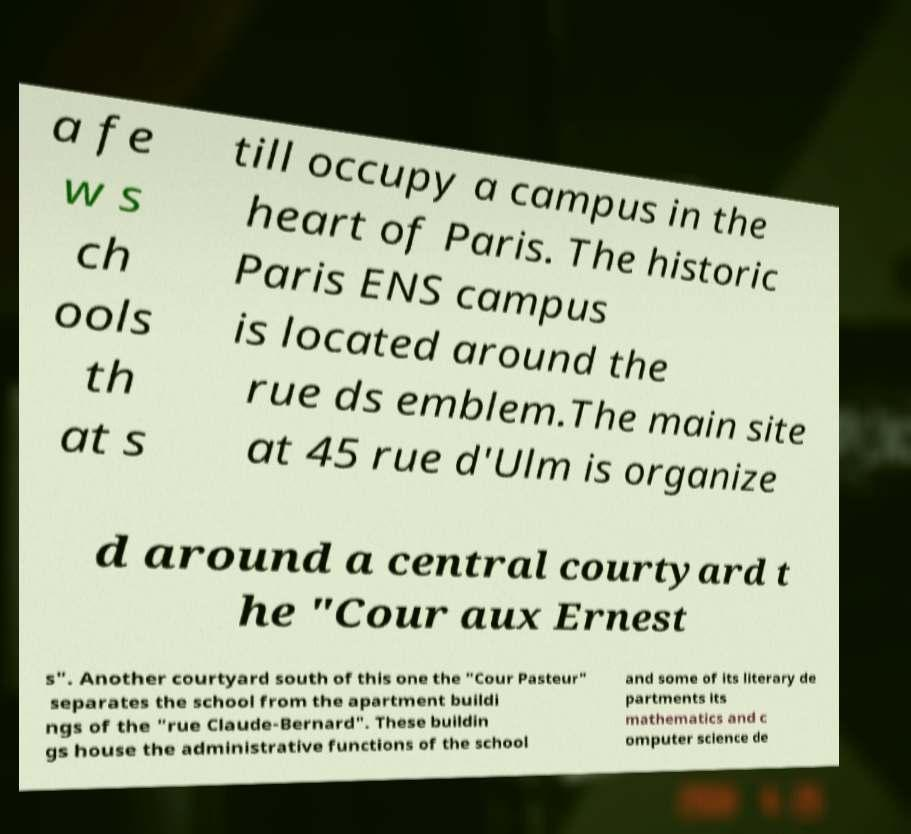What messages or text are displayed in this image? I need them in a readable, typed format. a fe w s ch ools th at s till occupy a campus in the heart of Paris. The historic Paris ENS campus is located around the rue ds emblem.The main site at 45 rue d'Ulm is organize d around a central courtyard t he "Cour aux Ernest s". Another courtyard south of this one the "Cour Pasteur" separates the school from the apartment buildi ngs of the "rue Claude-Bernard". These buildin gs house the administrative functions of the school and some of its literary de partments its mathematics and c omputer science de 